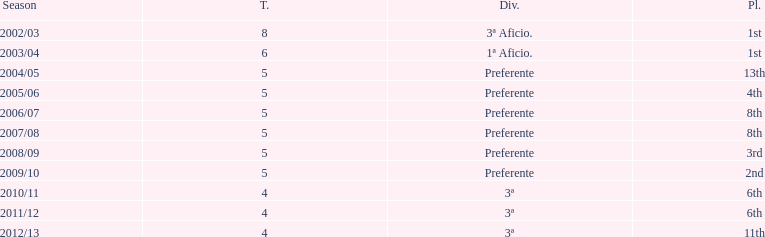What was the number of wins for preferente? 6. 